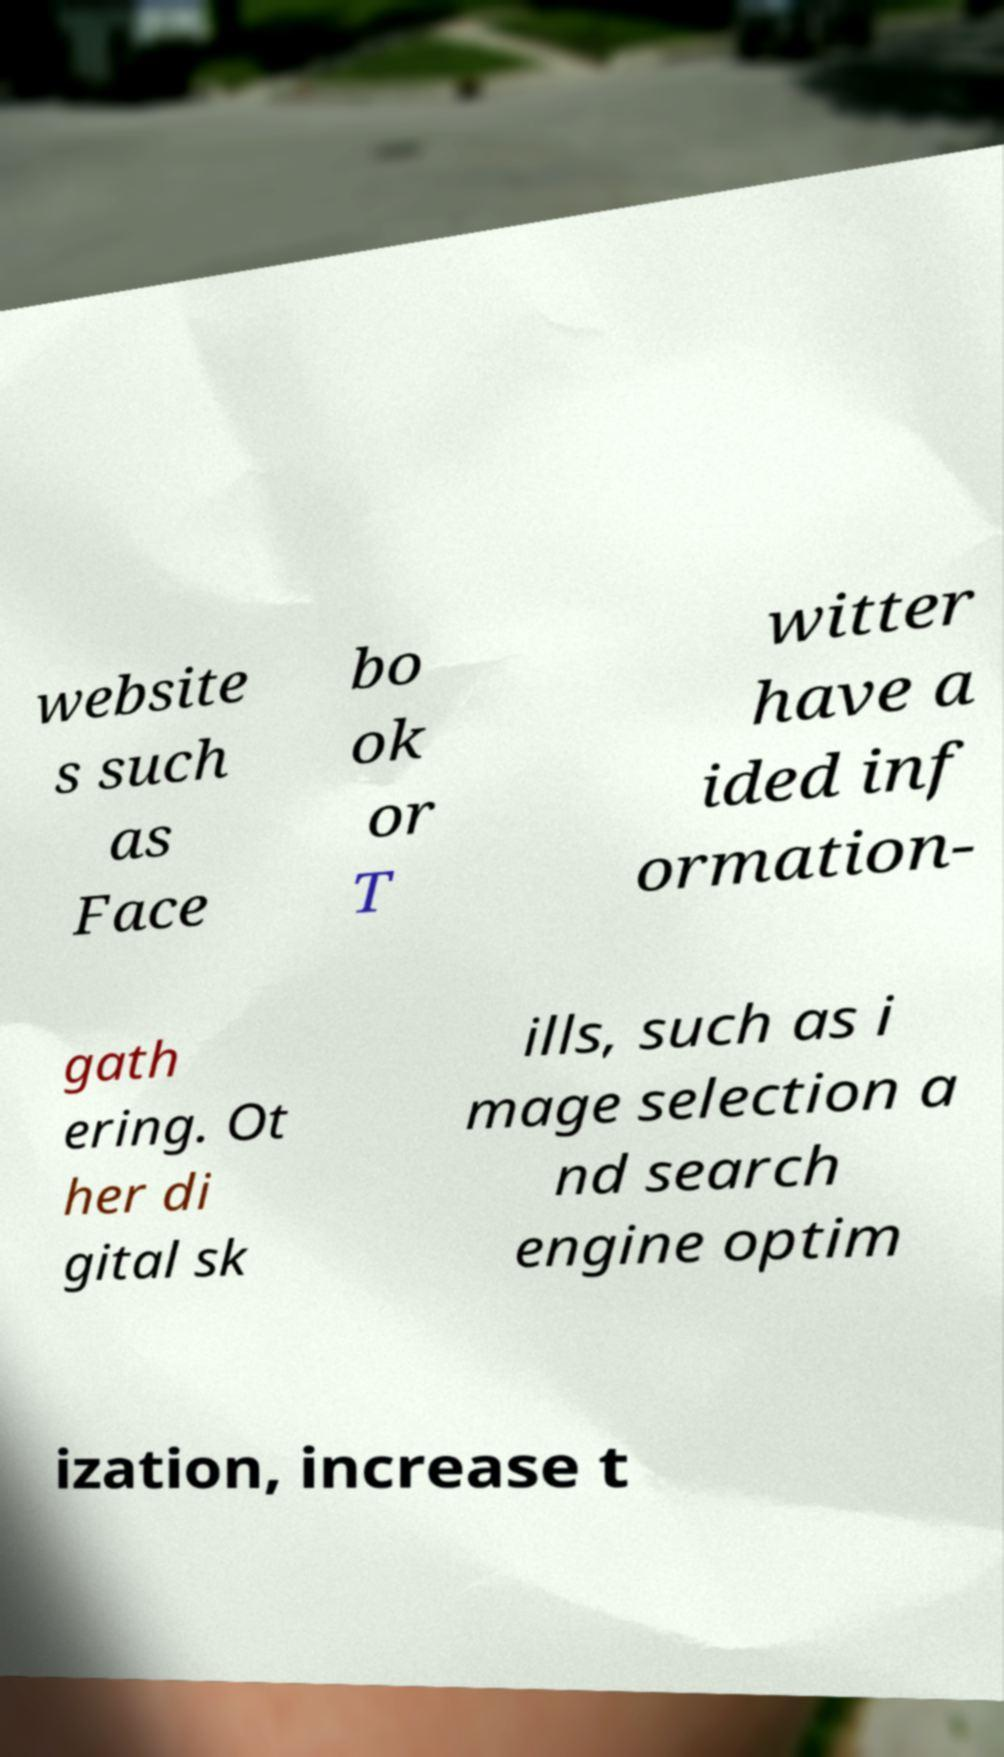There's text embedded in this image that I need extracted. Can you transcribe it verbatim? website s such as Face bo ok or T witter have a ided inf ormation- gath ering. Ot her di gital sk ills, such as i mage selection a nd search engine optim ization, increase t 